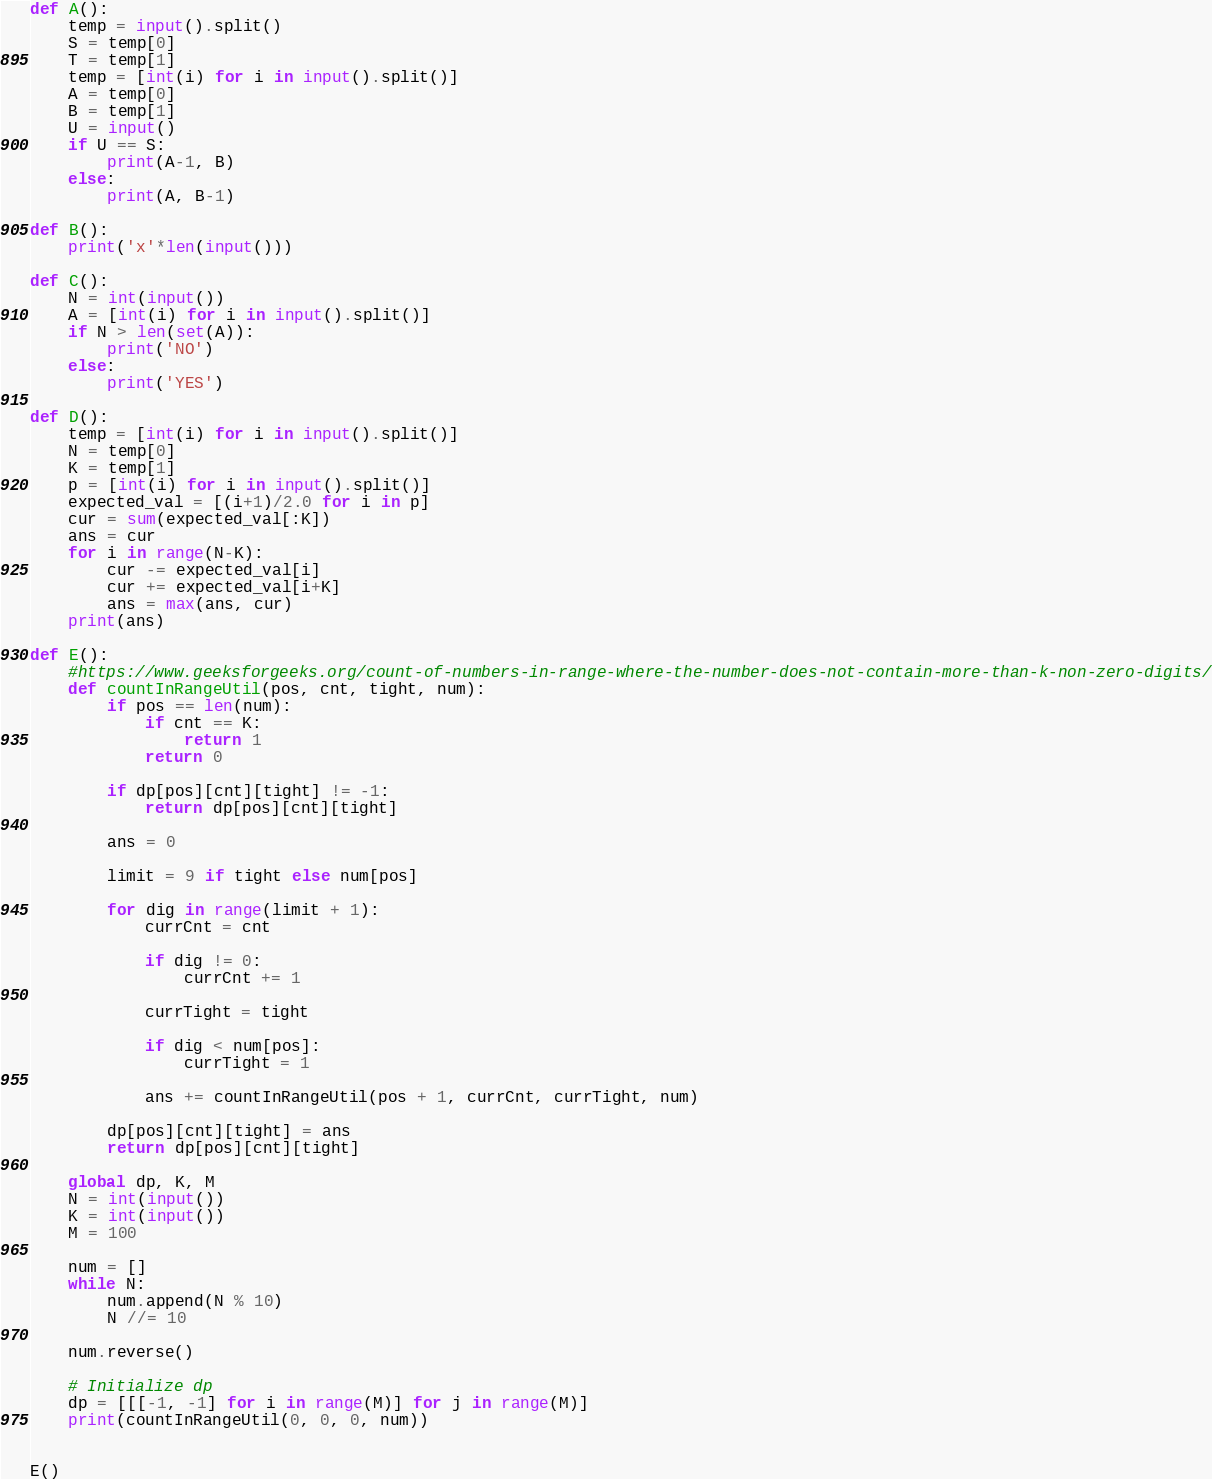<code> <loc_0><loc_0><loc_500><loc_500><_Python_>def A():
    temp = input().split()
    S = temp[0]
    T = temp[1]
    temp = [int(i) for i in input().split()]
    A = temp[0]
    B = temp[1]
    U = input()
    if U == S:
        print(A-1, B)
    else:
        print(A, B-1)

def B():
    print('x'*len(input()))

def C():
    N = int(input())
    A = [int(i) for i in input().split()]
    if N > len(set(A)):
        print('NO')
    else:
        print('YES')

def D():
    temp = [int(i) for i in input().split()]
    N = temp[0]
    K = temp[1]
    p = [int(i) for i in input().split()]
    expected_val = [(i+1)/2.0 for i in p]
    cur = sum(expected_val[:K])
    ans = cur
    for i in range(N-K):
        cur -= expected_val[i]
        cur += expected_val[i+K]
        ans = max(ans, cur)
    print(ans)

def E():
    #https://www.geeksforgeeks.org/count-of-numbers-in-range-where-the-number-does-not-contain-more-than-k-non-zero-digits/
    def countInRangeUtil(pos, cnt, tight, num): 
        if pos == len(num): 
            if cnt == K: 
                return 1
            return 0
    
        if dp[pos][cnt][tight] != -1: 
            return dp[pos][cnt][tight] 
    
        ans = 0
    
        limit = 9 if tight else num[pos] 
    
        for dig in range(limit + 1): 
            currCnt = cnt 
    
            if dig != 0: 
                currCnt += 1
    
            currTight = tight 
    
            if dig < num[pos]: 
                currTight = 1
    
            ans += countInRangeUtil(pos + 1, currCnt, currTight, num) 
    
        dp[pos][cnt][tight] = ans 
        return dp[pos][cnt][tight] 

    global dp, K, M 
    N = int(input())
    K = int(input())
    M = 100
  
    num = [] 
    while N: 
        num.append(N % 10) 
        N //= 10
  
    num.reverse() 
  
    # Initialize dp 
    dp = [[[-1, -1] for i in range(M)] for j in range(M)] 
    print(countInRangeUtil(0, 0, 0, num)) 
  

E()</code> 